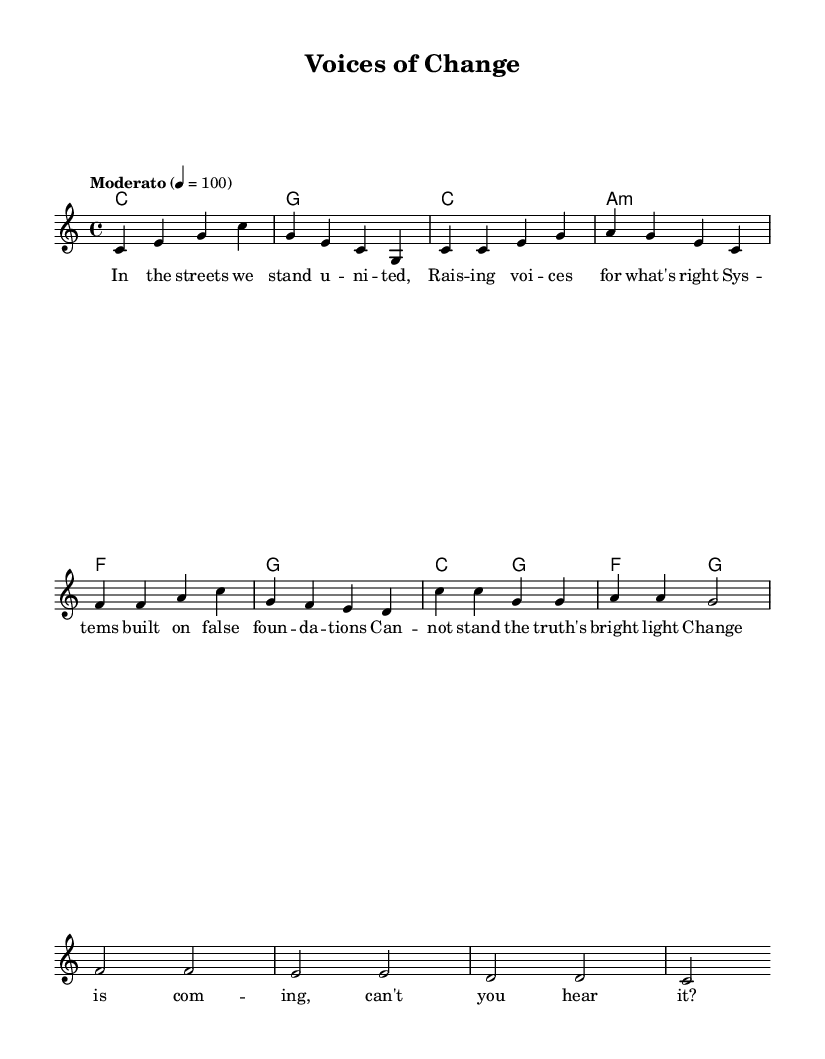What is the key signature of this music? The key signature is indicated using the \key command at the beginning of the score. It shows C major, which has no sharps or flats visually represented in the sheet music.
Answer: C major What is the time signature of this music? The time signature is provided by the \time command at the start of the score. Here, it is noted as 4/4, meaning there are four beats per measure, and the quarter note gets one beat.
Answer: 4/4 What is the tempo marking for this piece? The tempo marking is shown with the \tempo directive. It reads "Moderato," with a metronome marking of 100 beats per minute, indicating a moderate speed for performance.
Answer: Moderato, 100 How many measures are in the verse? The verse's length can be counted by looking at the number of distinct groupings of notes in the melody part, which in this case consists of four measures.
Answer: 4 What is the harmony used in the chorus? By examining the chord mode section beneath the melody, the harmony for the chorus consists of the triads C major and G major as well as an F major chord. Each chord coincides with the melody notes.
Answer: C, G, F How many syllables are in the lyric line "In the streets we stand united"? Counting the syllables in the lyric line, there are 8 distinct syllables represented in the score. Each word contributes to the overall count as per the lyric mode.
Answer: 8 What is the central theme represented in the lyrics? By analyzing the lyrics, the central theme revolves around systemic change and equality, emphasizing activism and collective action against inequalities evident in their phrasing.
Answer: Change and equality 